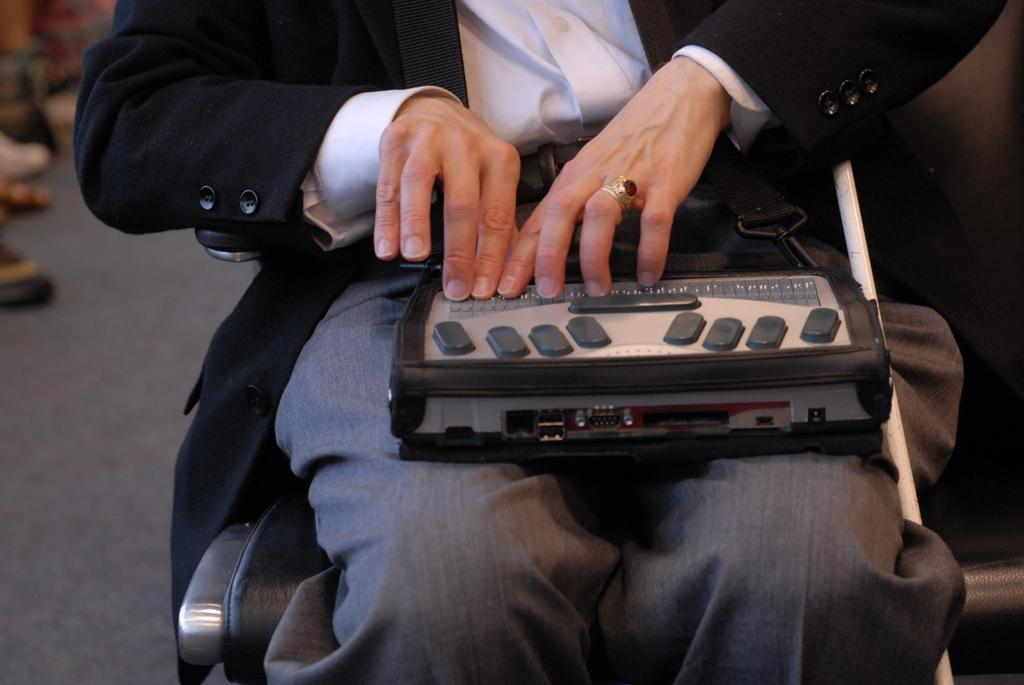What is the main subject of the image? There is a person in the image. What is the person doing in the image? The person is sitting on a chair. What is the person holding in the image? The person is holding a musical instrument on their lap. What type of advertisement can be seen on the musical instrument in the image? There is no advertisement present on the musical instrument in the image. 